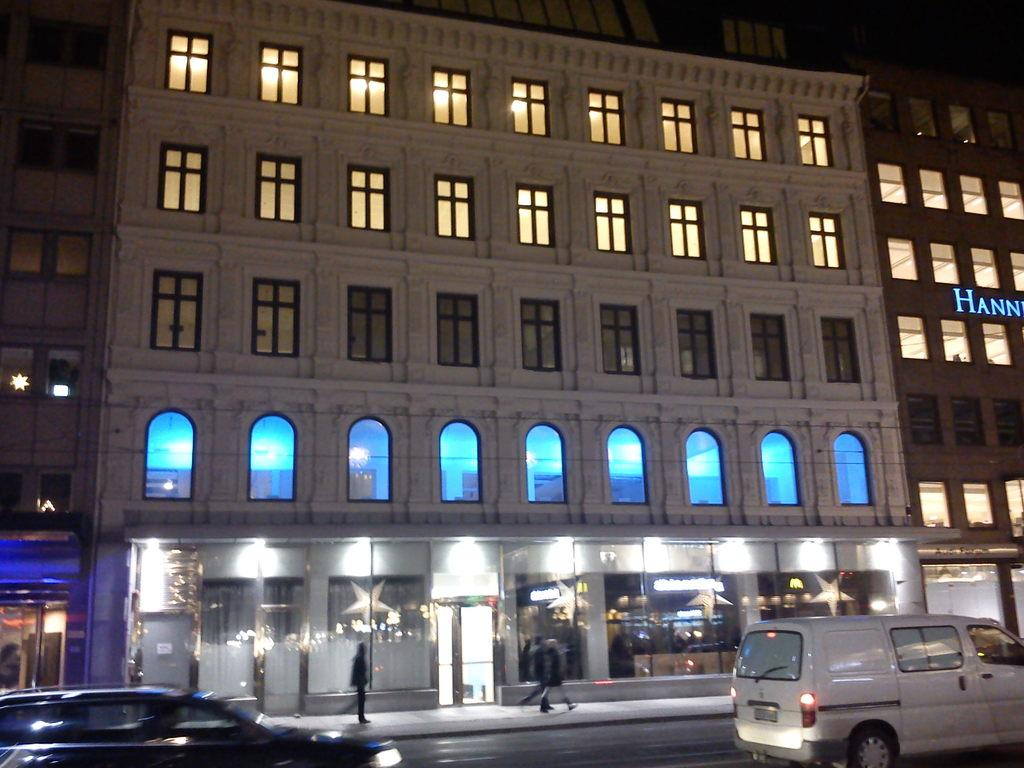What type of structure is present in the image? There is a building in the image. What features can be observed on the building? The building has windows and text on it. What else can be seen in the image besides the building? There are vehicles, stars, doors, and persons visible in the image. How many pizzas are being raked by the person in the image? There are no pizzas or rakes present in the image. 